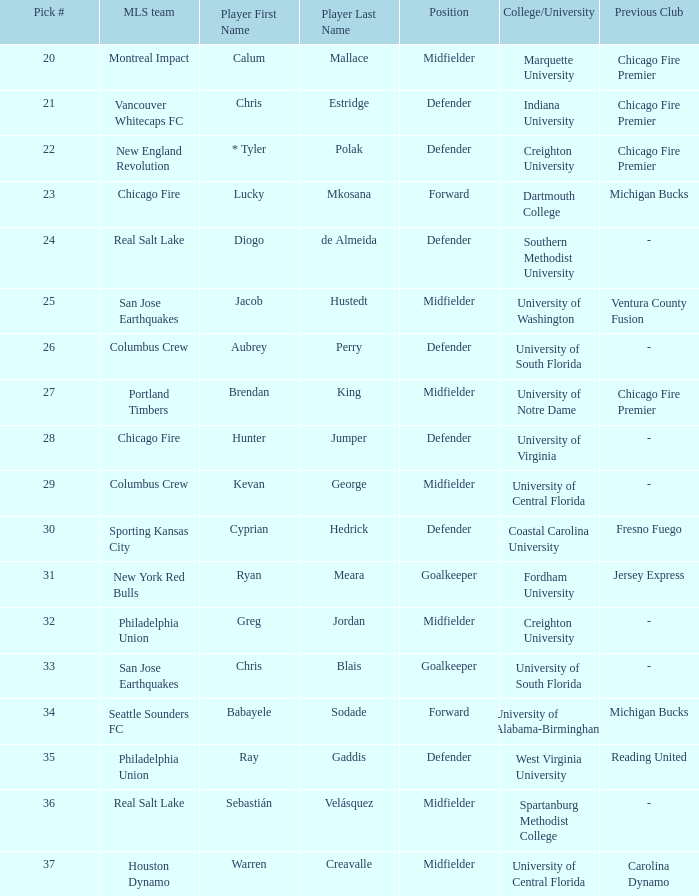I'm looking to parse the entire table for insights. Could you assist me with that? {'header': ['Pick #', 'MLS team', 'Player First Name', 'Player Last Name', 'Position', 'College/University', 'Previous Club'], 'rows': [['20', 'Montreal Impact', 'Calum', 'Mallace', 'Midfielder', 'Marquette University', 'Chicago Fire Premier'], ['21', 'Vancouver Whitecaps FC', 'Chris', 'Estridge', 'Defender', 'Indiana University', 'Chicago Fire Premier'], ['22', 'New England Revolution', '* Tyler', 'Polak', 'Defender', 'Creighton University', 'Chicago Fire Premier'], ['23', 'Chicago Fire', 'Lucky', 'Mkosana', 'Forward', 'Dartmouth College', 'Michigan Bucks'], ['24', 'Real Salt Lake', 'Diogo', 'de Almeida', 'Defender', 'Southern Methodist University', '-'], ['25', 'San Jose Earthquakes', 'Jacob', 'Hustedt', 'Midfielder', 'University of Washington', 'Ventura County Fusion'], ['26', 'Columbus Crew', 'Aubrey', 'Perry', 'Defender', 'University of South Florida', '-'], ['27', 'Portland Timbers', 'Brendan', 'King', 'Midfielder', 'University of Notre Dame', 'Chicago Fire Premier'], ['28', 'Chicago Fire', 'Hunter', 'Jumper', 'Defender', 'University of Virginia', '-'], ['29', 'Columbus Crew', 'Kevan', 'George', 'Midfielder', 'University of Central Florida', '-'], ['30', 'Sporting Kansas City', 'Cyprian', 'Hedrick', 'Defender', 'Coastal Carolina University', 'Fresno Fuego'], ['31', 'New York Red Bulls', 'Ryan', 'Meara', 'Goalkeeper', 'Fordham University', 'Jersey Express'], ['32', 'Philadelphia Union', 'Greg', 'Jordan', 'Midfielder', 'Creighton University', '-'], ['33', 'San Jose Earthquakes', 'Chris', 'Blais', 'Goalkeeper', 'University of South Florida', '-'], ['34', 'Seattle Sounders FC', 'Babayele', 'Sodade', 'Forward', 'University of Alabama-Birmingham', 'Michigan Bucks'], ['35', 'Philadelphia Union', 'Ray', 'Gaddis', 'Defender', 'West Virginia University', 'Reading United'], ['36', 'Real Salt Lake', 'Sebastián', 'Velásquez', 'Midfielder', 'Spartanburg Methodist College', '-'], ['37', 'Houston Dynamo', 'Warren', 'Creavalle', 'Midfielder', 'University of Central Florida', 'Carolina Dynamo']]} Who was pick number 34? Babayele Sodade. 